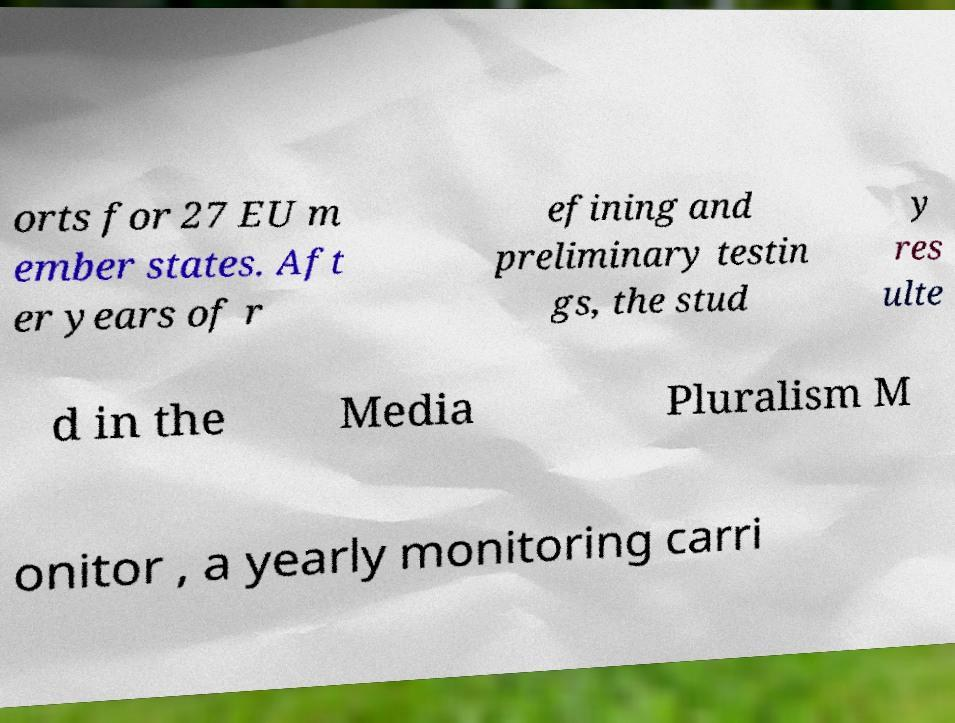For documentation purposes, I need the text within this image transcribed. Could you provide that? orts for 27 EU m ember states. Aft er years of r efining and preliminary testin gs, the stud y res ulte d in the Media Pluralism M onitor , a yearly monitoring carri 